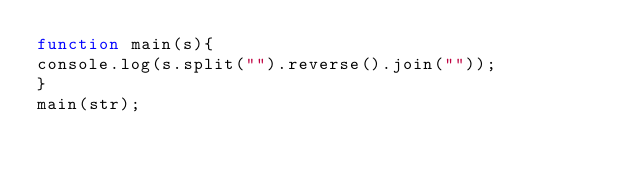<code> <loc_0><loc_0><loc_500><loc_500><_JavaScript_>function main(s){
console.log(s.split("").reverse().join(""));
}
main(str);</code> 